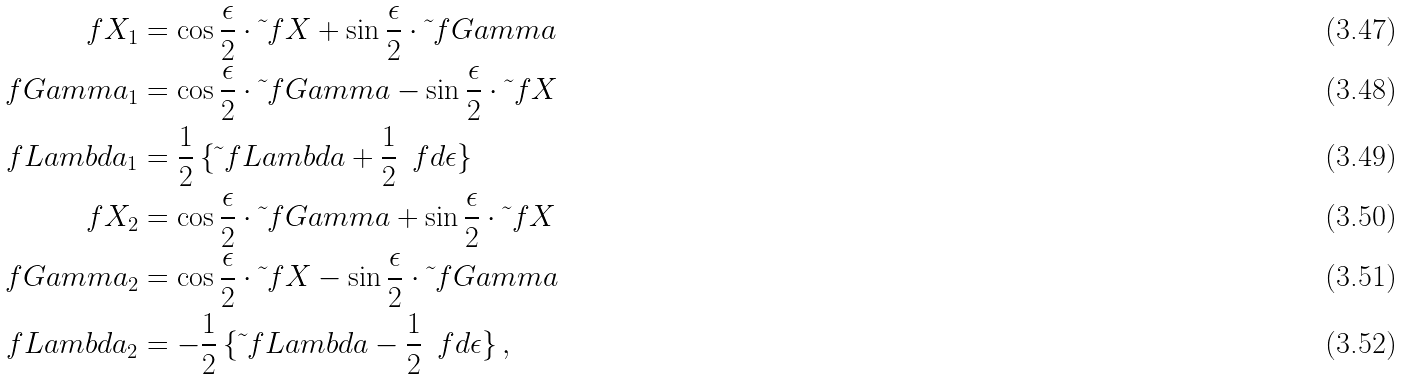Convert formula to latex. <formula><loc_0><loc_0><loc_500><loc_500>\ f X _ { 1 } & = \cos \frac { \epsilon } { 2 } \cdot \tilde { \ } f X + \sin \frac { \epsilon } { 2 } \cdot \tilde { \ } f G a m m a \\ \ f G a m m a _ { 1 } & = \cos \frac { \epsilon } { 2 } \cdot \tilde { \ } f G a m m a - \sin \frac { \epsilon } { 2 } \cdot \tilde { \ } f X \\ \ f L a m b d a _ { 1 } & = \frac { 1 } { 2 } \, \{ \tilde { \ } f L a m b d a + \frac { 1 } { 2 } \, \ f d \epsilon \} \\ \ f X _ { 2 } & = \cos \frac { \epsilon } { 2 } \cdot \tilde { \ } f G a m m a + \sin \frac { \epsilon } { 2 } \cdot \tilde { \ } f X \\ \ f G a m m a _ { 2 } & = \cos \frac { \epsilon } { 2 } \cdot \tilde { \ } f X - \sin \frac { \epsilon } { 2 } \cdot \tilde { \ } f G a m m a \\ \ f L a m b d a _ { 2 } & = - \frac { 1 } { 2 } \, \{ \tilde { \ } f L a m b d a - \frac { 1 } { 2 } \, \ f d \epsilon \} \, ,</formula> 